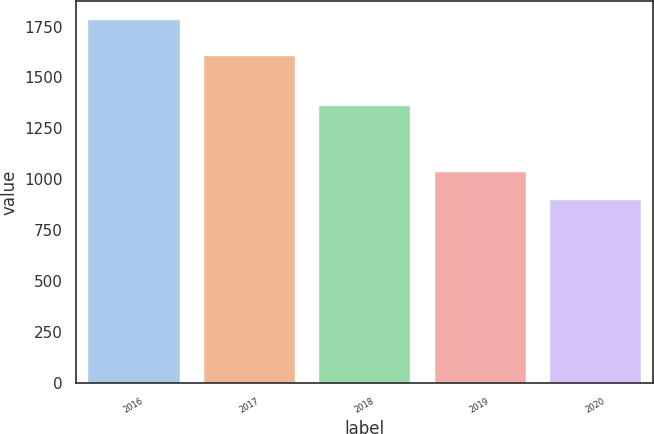<chart> <loc_0><loc_0><loc_500><loc_500><bar_chart><fcel>2016<fcel>2017<fcel>2018<fcel>2019<fcel>2020<nl><fcel>1785<fcel>1612<fcel>1365<fcel>1039<fcel>902<nl></chart> 